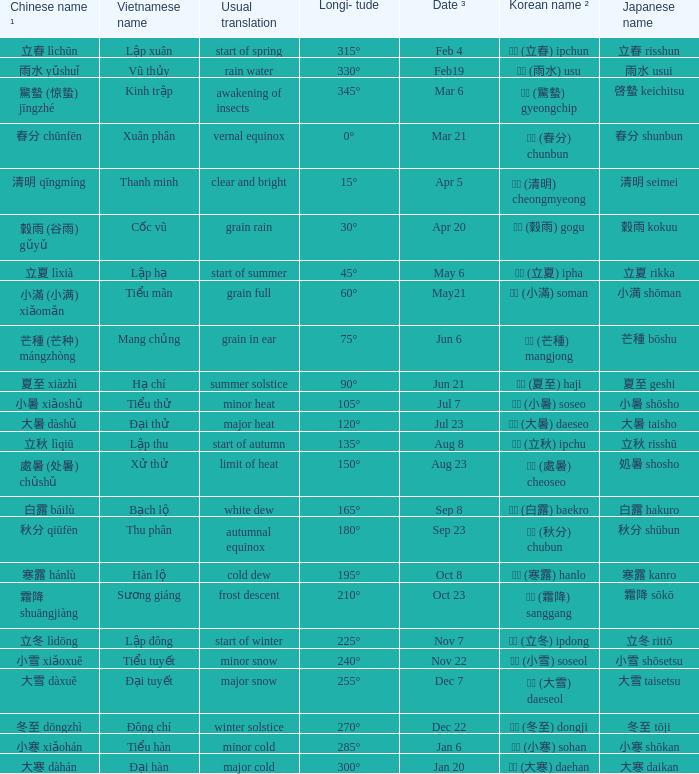WHich Usual translation is on sep 23? Autumnal equinox. 